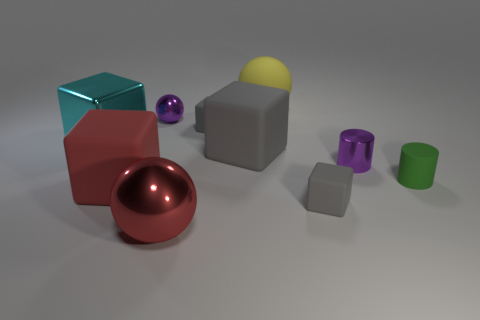How many gray blocks must be subtracted to get 1 gray blocks? 2 Subtract all cyan balls. How many gray cubes are left? 3 Subtract all cyan blocks. How many blocks are left? 4 Subtract 1 balls. How many balls are left? 2 Subtract all cyan cubes. How many cubes are left? 4 Subtract all green cubes. Subtract all blue balls. How many cubes are left? 5 Subtract all cylinders. How many objects are left? 8 Add 6 cyan shiny blocks. How many cyan shiny blocks exist? 7 Subtract 0 brown cylinders. How many objects are left? 10 Subtract all small green things. Subtract all green matte cylinders. How many objects are left? 8 